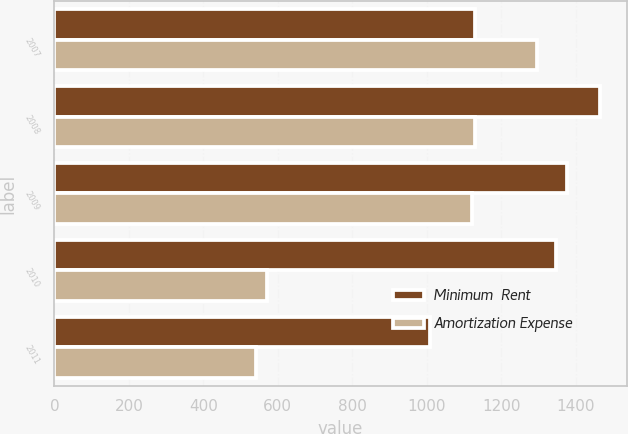Convert chart. <chart><loc_0><loc_0><loc_500><loc_500><stacked_bar_chart><ecel><fcel>2007<fcel>2008<fcel>2009<fcel>2010<fcel>2011<nl><fcel>Minimum  Rent<fcel>1130<fcel>1464<fcel>1377<fcel>1347<fcel>1008<nl><fcel>Amortization Expense<fcel>1297<fcel>1130<fcel>1121<fcel>570<fcel>541<nl></chart> 